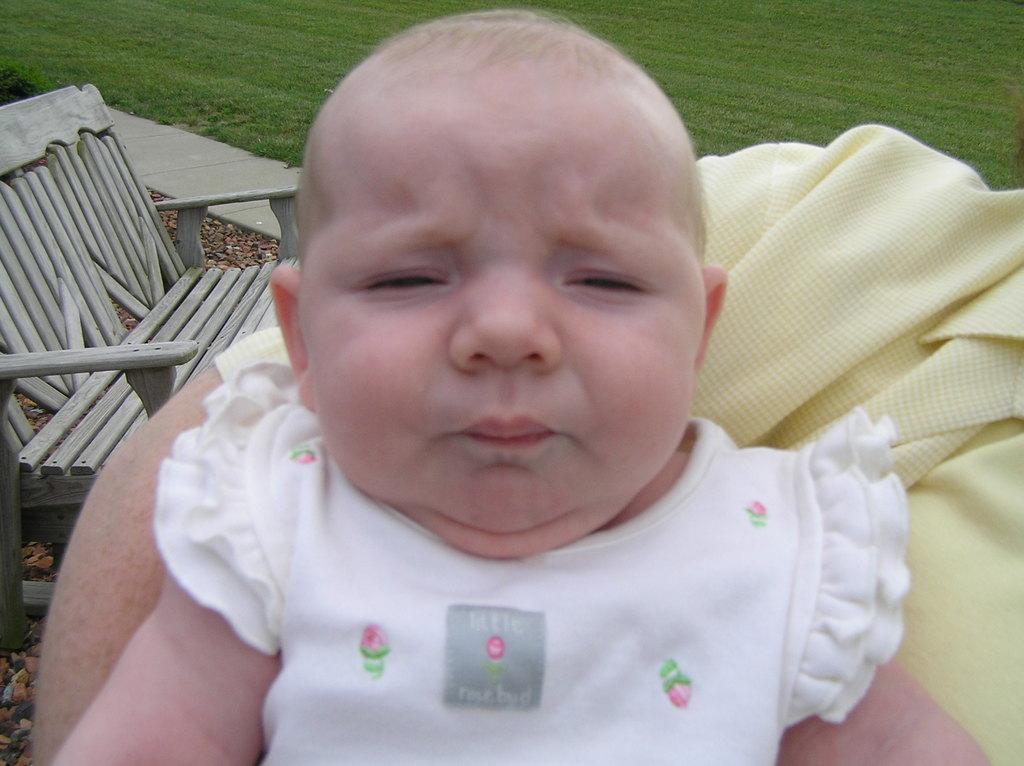Could you give a brief overview of what you see in this image? In this picture. I can see a baby and a wooden sofa on the left side and grass on the ground and i can see a yellow color cloth and there might be a woman. 